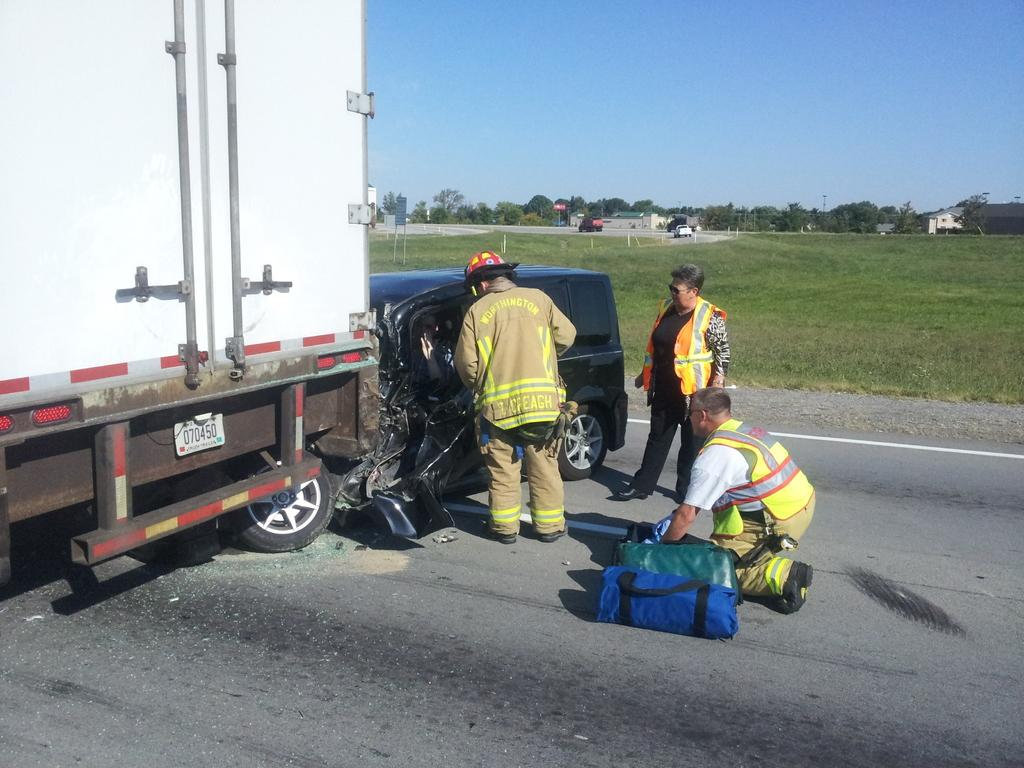What types of objects are in the image? There are vehicles in the image. Can you describe the condition of one of the vehicles? There is a damaged vehicle in the image. What is the ground covered with? The ground is covered with grass. What other natural elements can be seen in the image? Trees are present in the image. What man-made structures are visible? There are buildings in the image. What else can be seen in the image besides the vehicles, trees, and buildings? Poles are visible in the image. What part of the natural environment is visible in the image? The sky is visible in the image. What type of writer is sitting on the damaged vehicle in the image? There is no writer present in the image, and the damaged vehicle is not being used as a seat. 